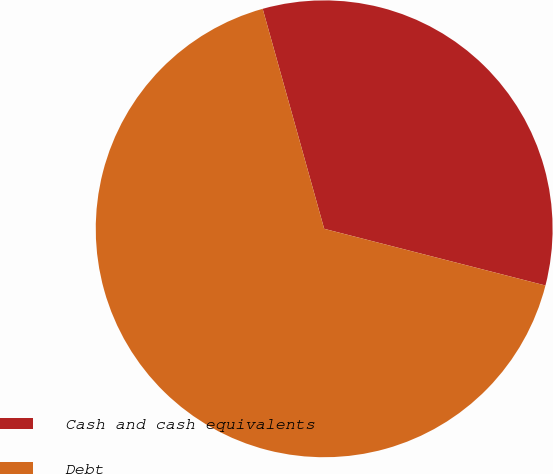<chart> <loc_0><loc_0><loc_500><loc_500><pie_chart><fcel>Cash and cash equivalents<fcel>Debt<nl><fcel>33.33%<fcel>66.67%<nl></chart> 